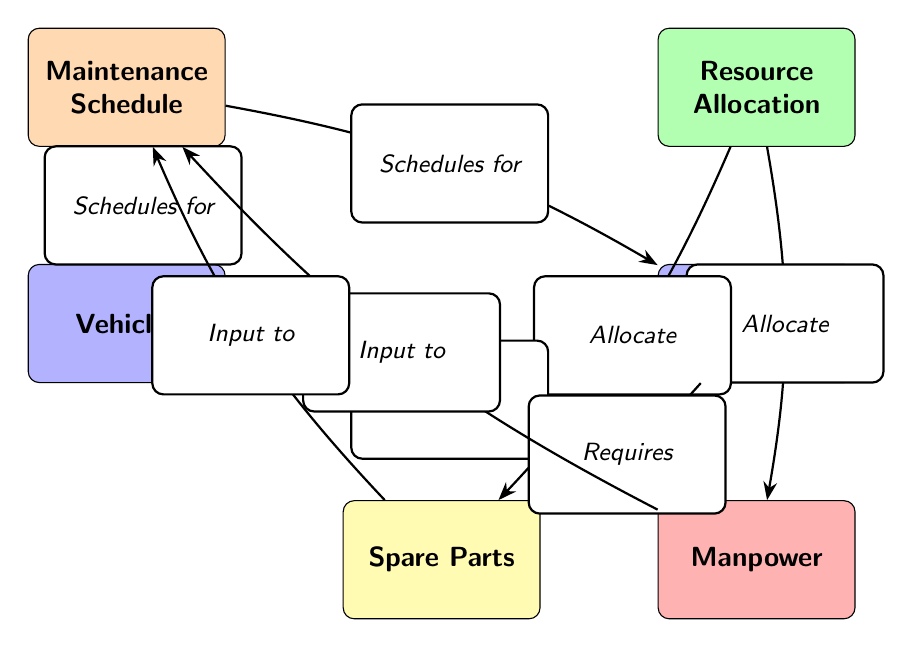What are the two main components in the diagram? The main components described in the diagram are "Maintenance Schedule" and "Resource Allocation," which are represented as the top-level nodes.
Answer: Maintenance Schedule, Resource Allocation How many nodes represent vehicles and equipment? There are two nodes, "Vehicles" and "Equipment," which represent the types of military assets in the diagram.
Answer: 2 What does the Maintenance Schedule provide for Vehicles? The Maintenance Schedule provides "Schedules for" Vehicles, indicating the planned maintenance activities specific to this type of military asset.
Answer: Schedules for Which node is associated with Manpower? The node associated with Manpower is "Resource Allocation," as it indicates where allocation decisions for manpower are made.
Answer: Resource Allocation How does Equipment relate to Spare Parts? Equipment "Requires" Spare Parts, indicating a direct need for resources to maintain or repair the equipment specified in the diagram.
Answer: Requires What type of input does Manpower provide to the Maintenance Schedule? Manpower provides "Input to" the Maintenance Schedule, which suggests that manpower resources affect maintenance planning.
Answer: Input to Which node is central to the relationship between all other nodes? The "Maintenance Schedule" node is central as it directly connects with both vehicles and their maintenance needs as well as the inputs from manpower and spare parts.
Answer: Maintenance Schedule What two activities does Resource Allocation involve? Resource Allocation involves allocating resources to "Manpower" and "Spare Parts," indicating the resources essential for operations and maintenance.
Answer: Allocate How many edges are there between nodes in the diagram? There are six edges in the diagram, representing relationships and flows of information among the various components.
Answer: 6 